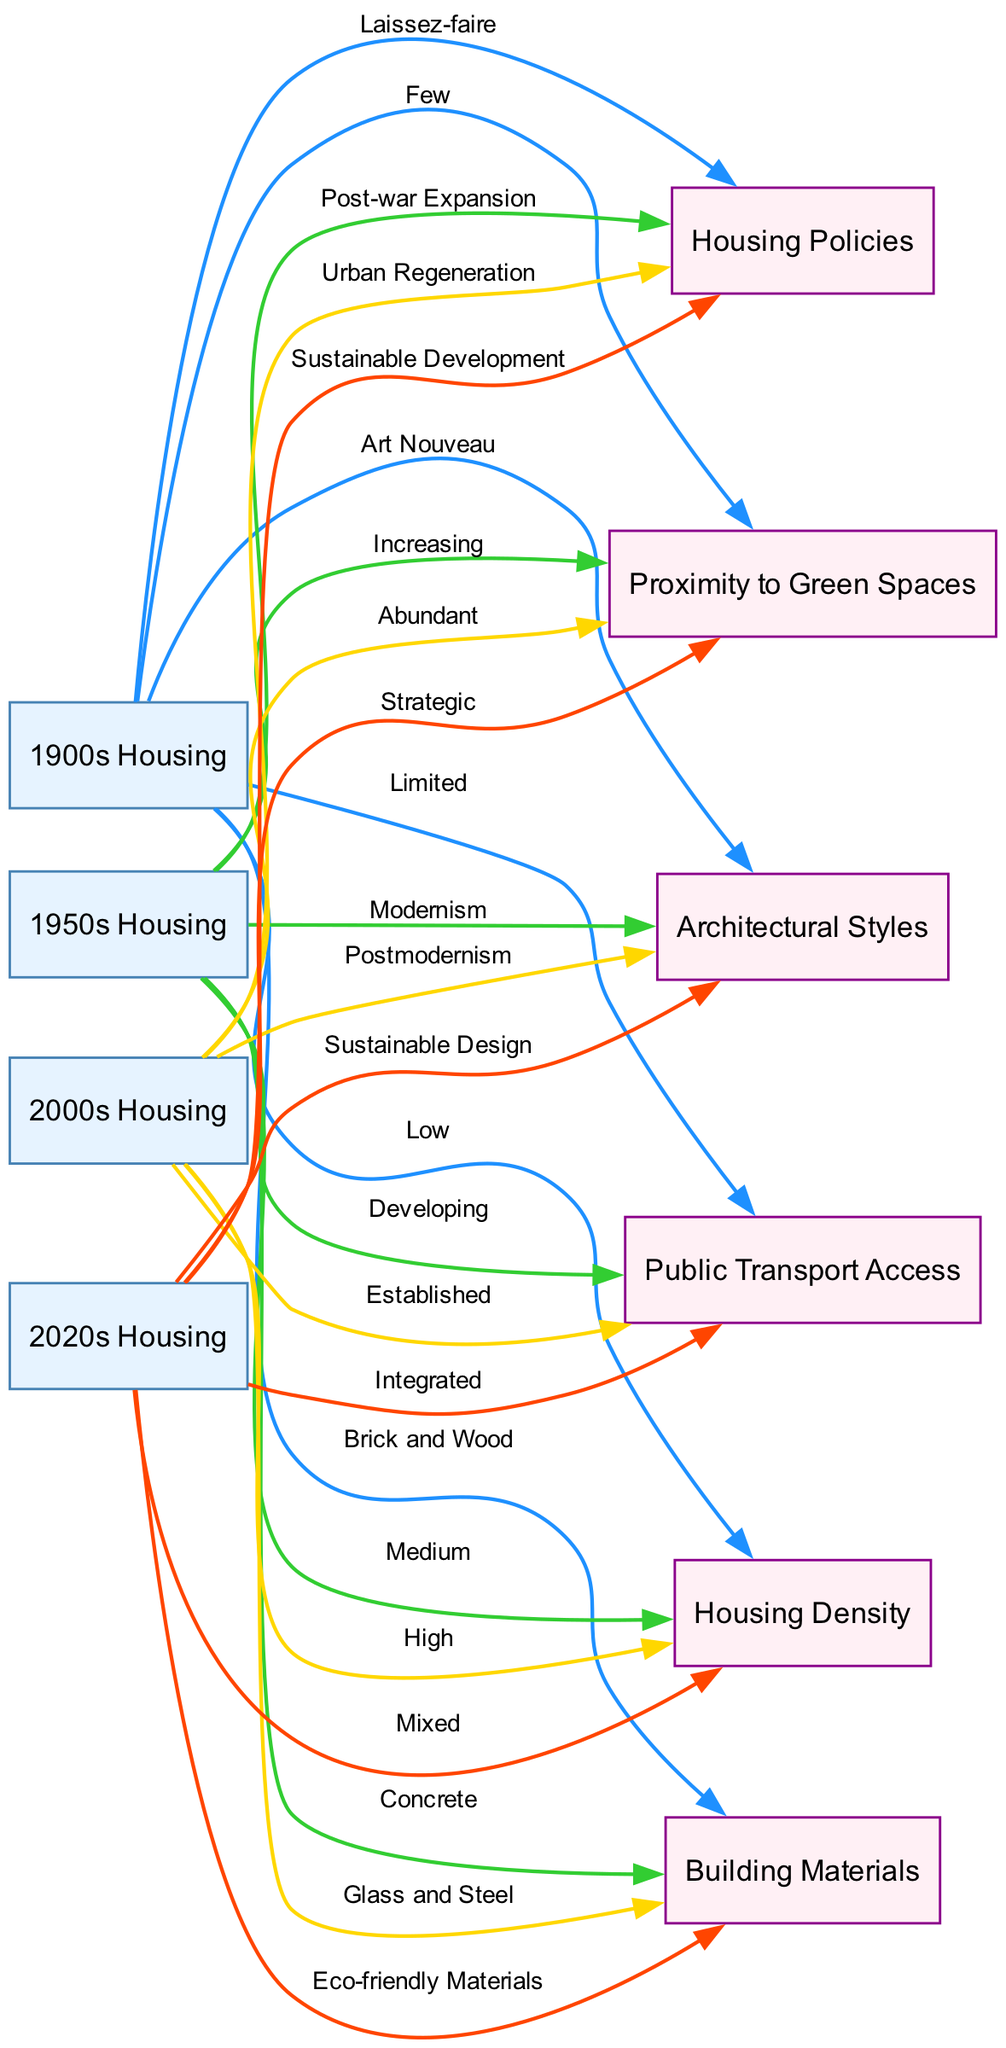What architectural style is associated with 1900s housing? The diagram connects the "1900s Housing" node to the "Architectural Styles" node with the label "Art Nouveau." This is the architectural style linked explicitly to 1900s housing.
Answer: Art Nouveau How has housing density changed from 1900 to 2020? The diagram shows a progression from "Low" housing density in 1900, to "Medium" in 1950, "High" in 2000, and finally "Mixed" in 2020. By following the edges for housing density through time, the trend can be established.
Answer: Mixed What building material was primarily used for housing in the 2000s? The edge between "2000s Housing" and "Building Materials" is labeled "Glass and Steel," indicating that these materials characterized housing during that decade.
Answer: Glass and Steel Which time period shows the greatest proximity to green spaces? Looking at the edges connected to "2020s Housing," we can see that it connects to "Proximity to Green Spaces" with the label "Strategic." Since the question is about the greatest proximity, the answer can only be found at the endpoint for this time period.
Answer: Strategic What has been the trend in public transport access from 1900 to 2020? The diagram shows a transition from "Limited" public transport access in 1900 to "Integrated" access in 2020 through the nodes connected, indicating an overall improvement in access over the years. Each step reflects a progressive increase in integration.
Answer: Integrated What type of housing policy was in effect in the 1950s? By tracing the edge from "1950s Housing" to "Housing Policies," one finds the label "Post-war Expansion," which reveals the housing policy characteristic of that era.
Answer: Post-war Expansion How many total nodes are there in the diagram? The diagram presents a total of 10 nodes, which consist of four time periods of housing and additional aspects related to architectural styles, building materials, housing density, public transport, proximity to green spaces, and housing policies.
Answer: 10 What does the edge label from 2000s housing to public transport indicate? The edge connects "2000s Housing" to "Public Transport Access" with the label "Established," indicating that by this time, public transport infrastructure was well developed in Schaerbeek. This can be read directly on the edge connecting these two nodes.
Answer: Established 